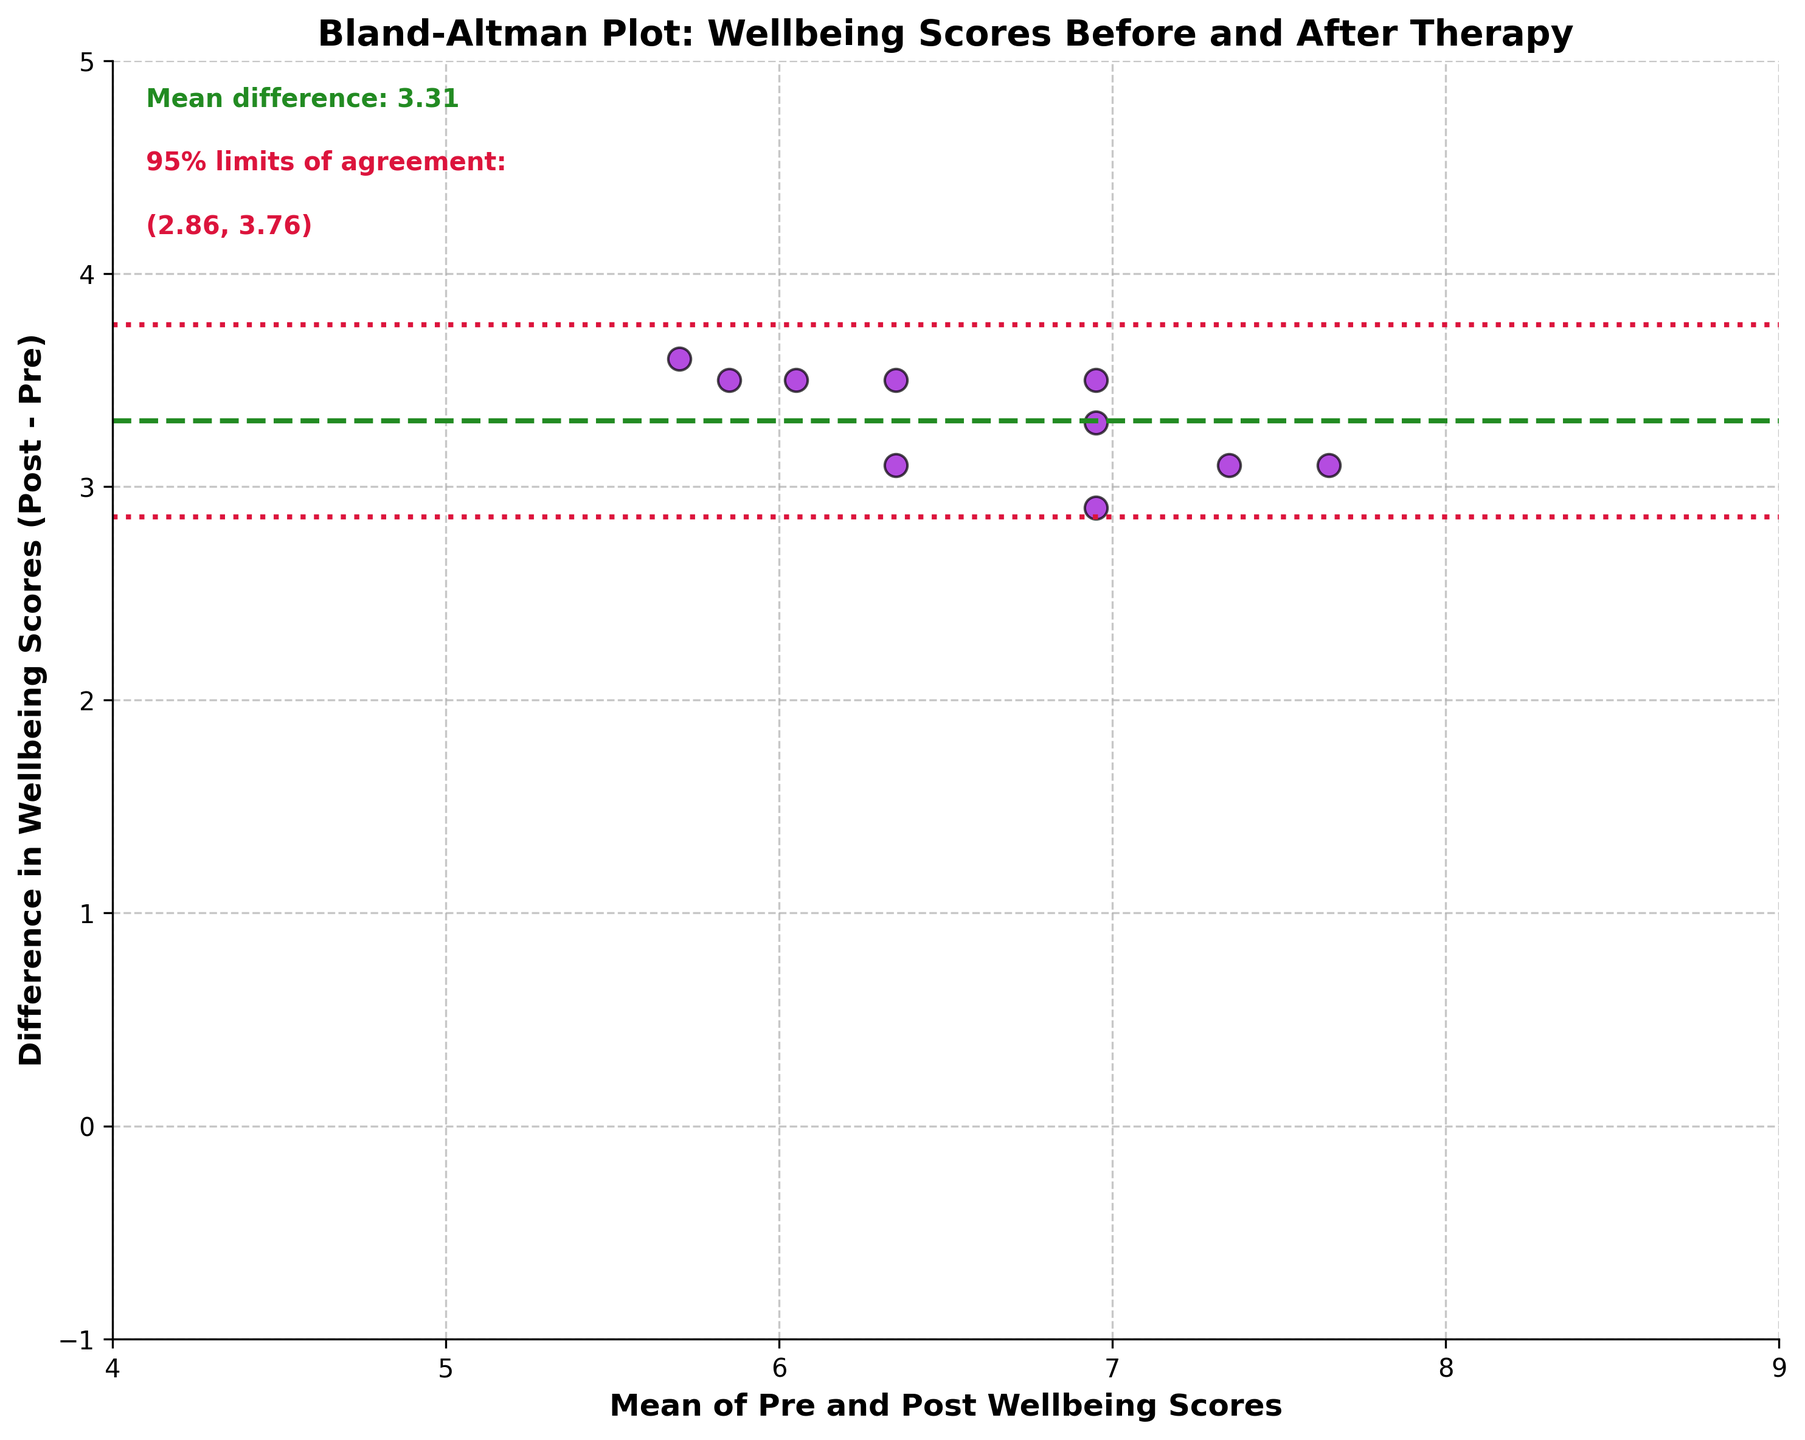What is the title of the plot? The title is located at the top of the plot and provides a summary of what the plot is about. In this case, it reads "Bland-Altman Plot: Wellbeing Scores Before and After Therapy."
Answer: Bland-Altman Plot: Wellbeing Scores Before and After Therapy What is the color of the scatter points in the plot? The scatter points, which represent the data points, are colored in dark violet with black edges, as observed in the plot.
Answer: Dark violet How many data points are plotted in the Bland-Altman plot? Each data point corresponds to a participant. By counting the scatter points in the plot, you find there are 10 points, matching the 10 participants in the data.
Answer: 10 What are the 95% limits of agreement indicated on the plot? The 95% limits of agreement are illustrated by the dotted lines and the red text annotations in the plot. They are calculated as Mean difference ± 1.96 * Standard Deviation. The limits indicated are about -0.48 and 4.08.
Answer: -0.48 and 4.08 What does the green dashed line represent in the plot? This line is horizontally aligned and represents the mean difference between the pre and post well-being scores, which is approximately stated as 2.9.
Answer: Mean difference Which participant has the greatest difference in their pre and post well-being scores? By identifying the largest vertical displacement from the x-axis (which represents the mean of pre and post scores), we see that Sarah's data point has the greatest difference, where her post score is significantly higher than her pre score.
Answer: Sarah Is the mean difference in well-being scores positive or negative? The green dashed line indicating the mean difference is above the x-axis, which means the post-treatment scores are generally higher than the pre-treatment scores, pointing to a positive mean difference.
Answer: Positive What can you conclude if a data point is significantly outside the 95% limits of agreement? A data point outside the 95% limits indicates that this participant's difference in pre and post well-being scores deviates significantly from the overall trend and might be an outlier.
Answer: Indicates a significant deviance from the trend Are there more data points above or below the mean difference line? By visually counting the scatter points relative to the green dashed line, one can see there are generally more points below the mean difference line than above.
Answer: Below 